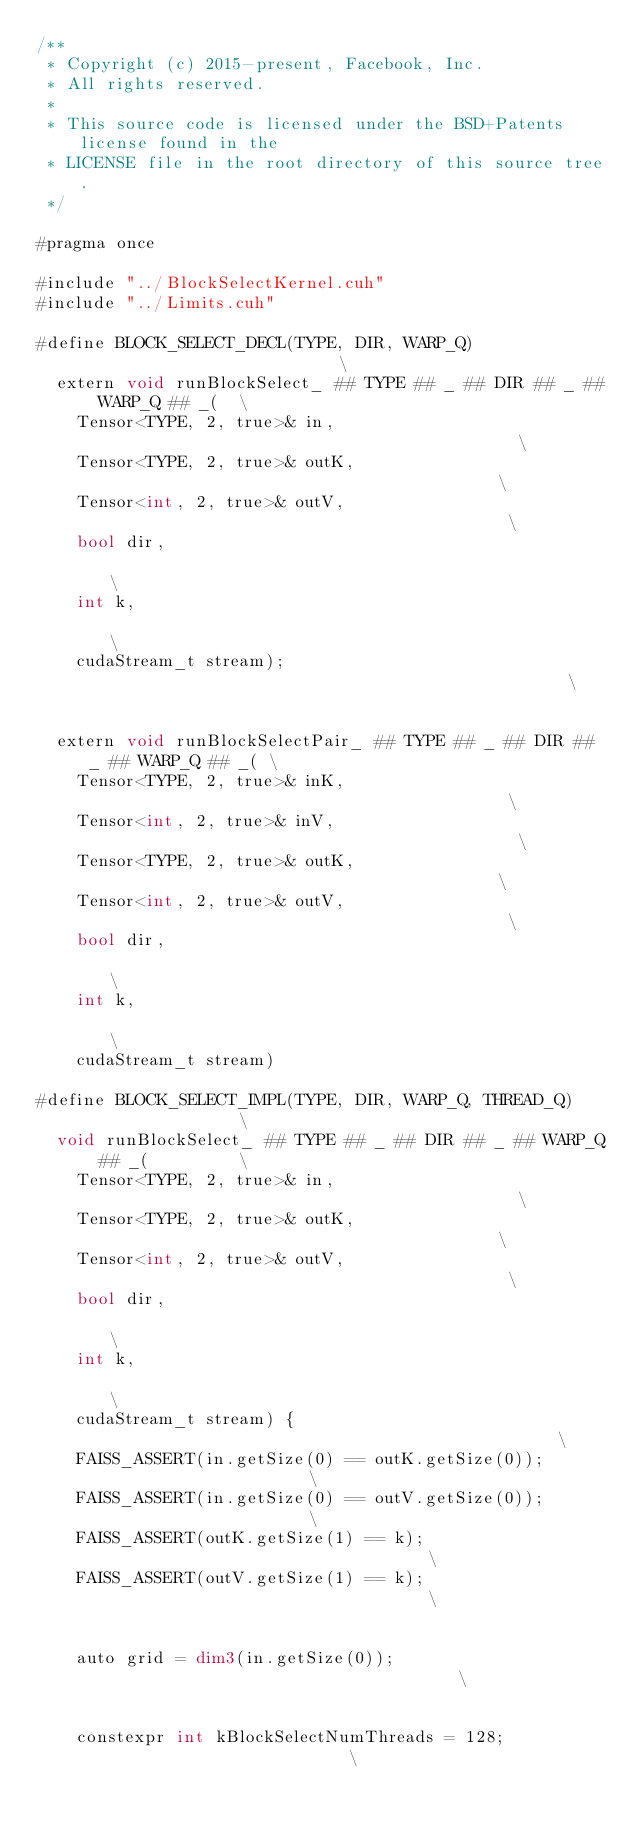<code> <loc_0><loc_0><loc_500><loc_500><_Cuda_>/**
 * Copyright (c) 2015-present, Facebook, Inc.
 * All rights reserved.
 *
 * This source code is licensed under the BSD+Patents license found in the
 * LICENSE file in the root directory of this source tree.
 */

#pragma once

#include "../BlockSelectKernel.cuh"
#include "../Limits.cuh"

#define BLOCK_SELECT_DECL(TYPE, DIR, WARP_Q)                            \
  extern void runBlockSelect_ ## TYPE ## _ ## DIR ## _ ## WARP_Q ## _(  \
    Tensor<TYPE, 2, true>& in,                                          \
    Tensor<TYPE, 2, true>& outK,                                        \
    Tensor<int, 2, true>& outV,                                         \
    bool dir,                                                           \
    int k,                                                              \
    cudaStream_t stream);                                               \
                                                                        \
  extern void runBlockSelectPair_ ## TYPE ## _ ## DIR ## _ ## WARP_Q ## _( \
    Tensor<TYPE, 2, true>& inK,                                         \
    Tensor<int, 2, true>& inV,                                          \
    Tensor<TYPE, 2, true>& outK,                                        \
    Tensor<int, 2, true>& outV,                                         \
    bool dir,                                                           \
    int k,                                                              \
    cudaStream_t stream)

#define BLOCK_SELECT_IMPL(TYPE, DIR, WARP_Q, THREAD_Q)                  \
  void runBlockSelect_ ## TYPE ## _ ## DIR ## _ ## WARP_Q ## _(         \
    Tensor<TYPE, 2, true>& in,                                          \
    Tensor<TYPE, 2, true>& outK,                                        \
    Tensor<int, 2, true>& outV,                                         \
    bool dir,                                                           \
    int k,                                                              \
    cudaStream_t stream) {                                              \
    FAISS_ASSERT(in.getSize(0) == outK.getSize(0));                     \
    FAISS_ASSERT(in.getSize(0) == outV.getSize(0));                     \
    FAISS_ASSERT(outK.getSize(1) == k);                                 \
    FAISS_ASSERT(outV.getSize(1) == k);                                 \
                                                                        \
    auto grid = dim3(in.getSize(0));                                    \
                                                                        \
    constexpr int kBlockSelectNumThreads = 128;                         \</code> 